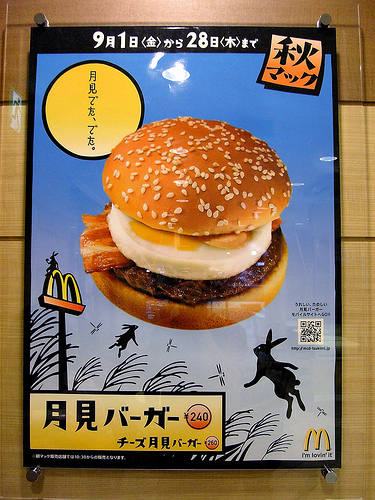<image>
Can you confirm if the burger is in the sky? Yes. The burger is contained within or inside the sky, showing a containment relationship. Is there a burger next to the bunny? No. The burger is not positioned next to the bunny. They are located in different areas of the scene. 